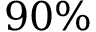<formula> <loc_0><loc_0><loc_500><loc_500>9 0 \%</formula> 